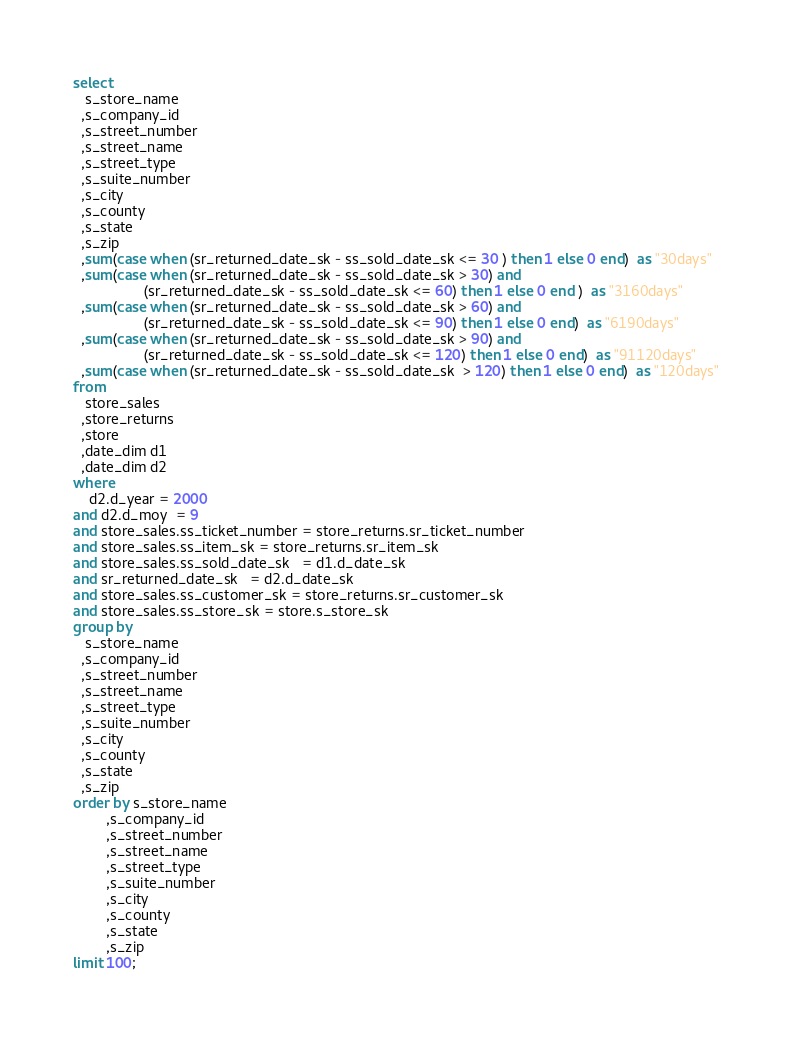Convert code to text. <code><loc_0><loc_0><loc_500><loc_500><_SQL_>
select  
   s_store_name
  ,s_company_id
  ,s_street_number
  ,s_street_name
  ,s_street_type
  ,s_suite_number
  ,s_city
  ,s_county
  ,s_state
  ,s_zip
  ,sum(case when (sr_returned_date_sk - ss_sold_date_sk <= 30 ) then 1 else 0 end)  as "30days"
  ,sum(case when (sr_returned_date_sk - ss_sold_date_sk > 30) and 
                 (sr_returned_date_sk - ss_sold_date_sk <= 60) then 1 else 0 end )  as "3160days" 
  ,sum(case when (sr_returned_date_sk - ss_sold_date_sk > 60) and 
                 (sr_returned_date_sk - ss_sold_date_sk <= 90) then 1 else 0 end)  as "6190days"
  ,sum(case when (sr_returned_date_sk - ss_sold_date_sk > 90) and
                 (sr_returned_date_sk - ss_sold_date_sk <= 120) then 1 else 0 end)  as "91120days" 
  ,sum(case when (sr_returned_date_sk - ss_sold_date_sk  > 120) then 1 else 0 end)  as "120days"
from
   store_sales
  ,store_returns
  ,store
  ,date_dim d1
  ,date_dim d2
where
    d2.d_year = 2000
and d2.d_moy  = 9
and store_sales.ss_ticket_number = store_returns.sr_ticket_number
and store_sales.ss_item_sk = store_returns.sr_item_sk
and store_sales.ss_sold_date_sk   = d1.d_date_sk
and sr_returned_date_sk   = d2.d_date_sk
and store_sales.ss_customer_sk = store_returns.sr_customer_sk
and store_sales.ss_store_sk = store.s_store_sk
group by
   s_store_name
  ,s_company_id
  ,s_street_number
  ,s_street_name
  ,s_street_type
  ,s_suite_number
  ,s_city
  ,s_county
  ,s_state
  ,s_zip
order by s_store_name
        ,s_company_id
        ,s_street_number
        ,s_street_name
        ,s_street_type
        ,s_suite_number
        ,s_city
        ,s_county
        ,s_state
        ,s_zip
limit 100;


</code> 